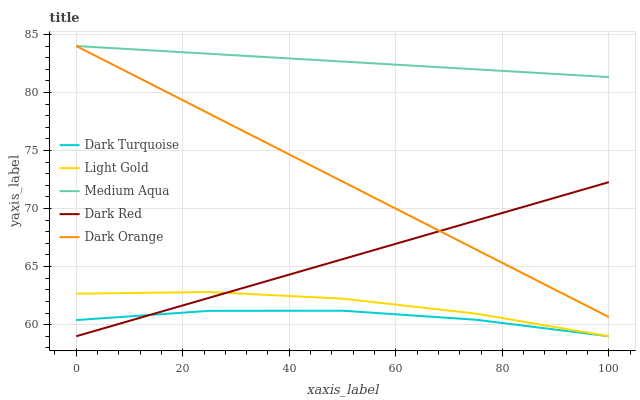Does Dark Turquoise have the minimum area under the curve?
Answer yes or no. Yes. Does Medium Aqua have the maximum area under the curve?
Answer yes or no. Yes. Does Light Gold have the minimum area under the curve?
Answer yes or no. No. Does Light Gold have the maximum area under the curve?
Answer yes or no. No. Is Dark Red the smoothest?
Answer yes or no. Yes. Is Dark Turquoise the roughest?
Answer yes or no. Yes. Is Light Gold the smoothest?
Answer yes or no. No. Is Light Gold the roughest?
Answer yes or no. No. Does Dark Orange have the lowest value?
Answer yes or no. No. Does Light Gold have the highest value?
Answer yes or no. No. Is Light Gold less than Medium Aqua?
Answer yes or no. Yes. Is Medium Aqua greater than Light Gold?
Answer yes or no. Yes. Does Light Gold intersect Medium Aqua?
Answer yes or no. No. 